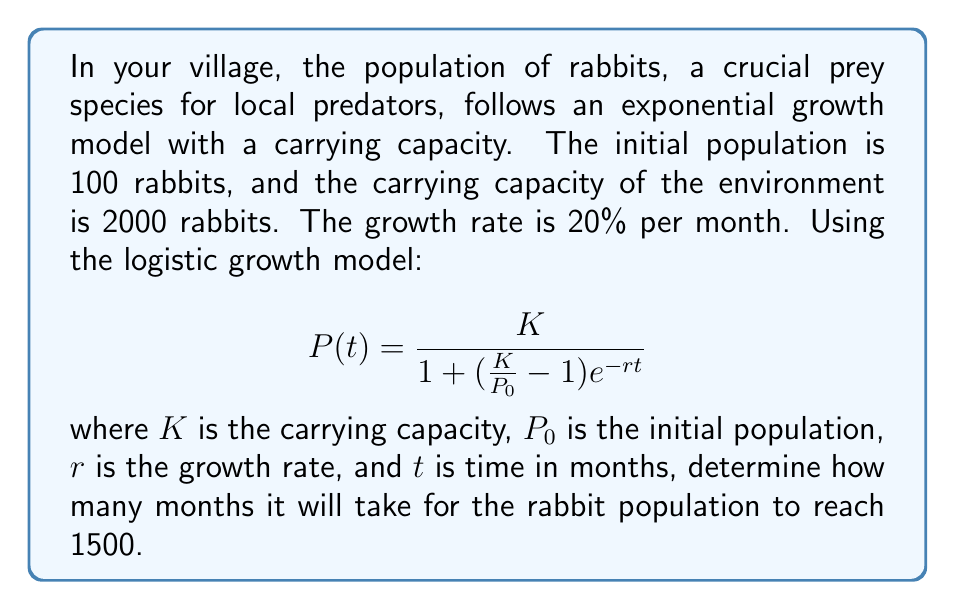Can you answer this question? To solve this problem, we'll use the given logistic growth model and the provided information:

$K = 2000$ (carrying capacity)
$P_0 = 100$ (initial population)
$r = 0.20$ (growth rate per month)
$P(t) = 1500$ (target population)

1) Substitute these values into the logistic growth equation:

   $$1500 = \frac{2000}{1 + (\frac{2000}{100} - 1)e^{-0.20t}}$$

2) Simplify the fraction inside the parentheses:

   $$1500 = \frac{2000}{1 + 19e^{-0.20t}}$$

3) Multiply both sides by the denominator:

   $$1500(1 + 19e^{-0.20t}) = 2000$$

4) Expand the left side:

   $$1500 + 28500e^{-0.20t} = 2000$$

5) Subtract 1500 from both sides:

   $$28500e^{-0.20t} = 500$$

6) Divide both sides by 28500:

   $$e^{-0.20t} = \frac{500}{28500} = \frac{1}{57}$$

7) Take the natural log of both sides:

   $$-0.20t = \ln(\frac{1}{57})$$

8) Divide both sides by -0.20:

   $$t = \frac{\ln(57)}{0.20}$$

9) Calculate the result:

   $$t \approx 20.28$$

Since we're dealing with whole months, we round up to the nearest integer.
Answer: It will take 21 months for the rabbit population to reach 1500. 